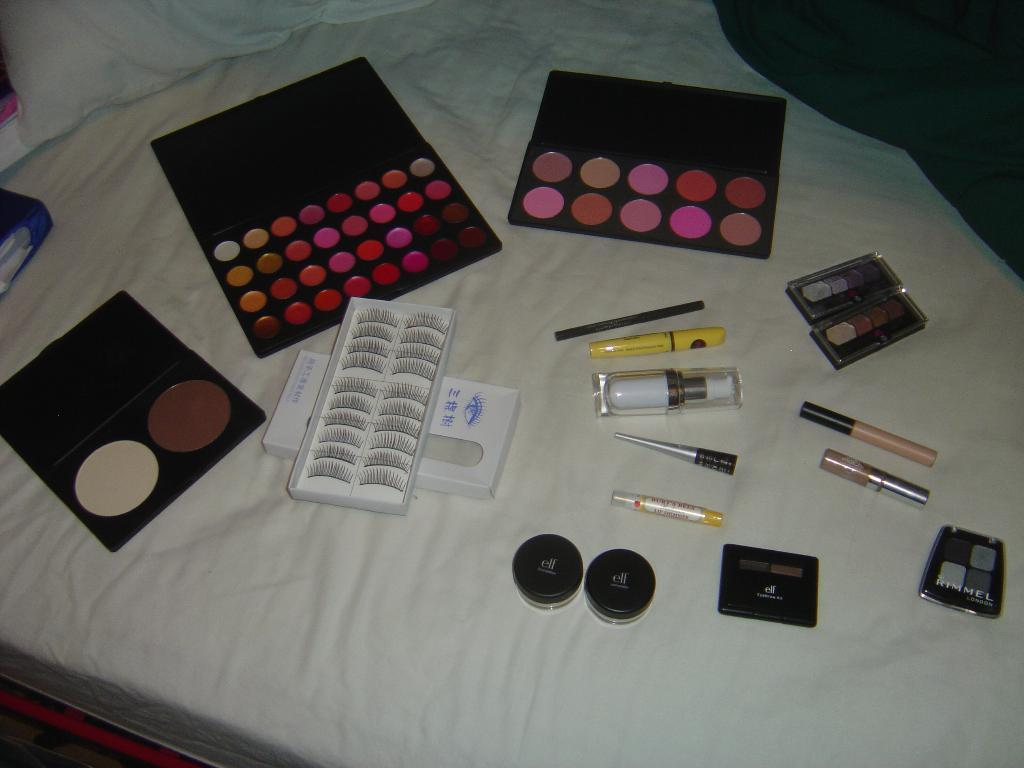What type of kit is visible in the image? There is a makeup kit in the image. What else can be seen related to makeup in the image? There is an eyelashes box in the image. What other items are present in the image? There are bottles in the image. Where are these items placed? The items are placed on a white bed. What else can be seen on the bed? A pillow is visible at the top of the image. Is there any fabric visible in the image? Yes, there is a cloth in the image. What type of scarf is draped over the makeup kit in the image? There is no scarf present in the image; it only features a makeup kit, an eyelashes box, bottles, a white bed, a pillow, and a cloth. 